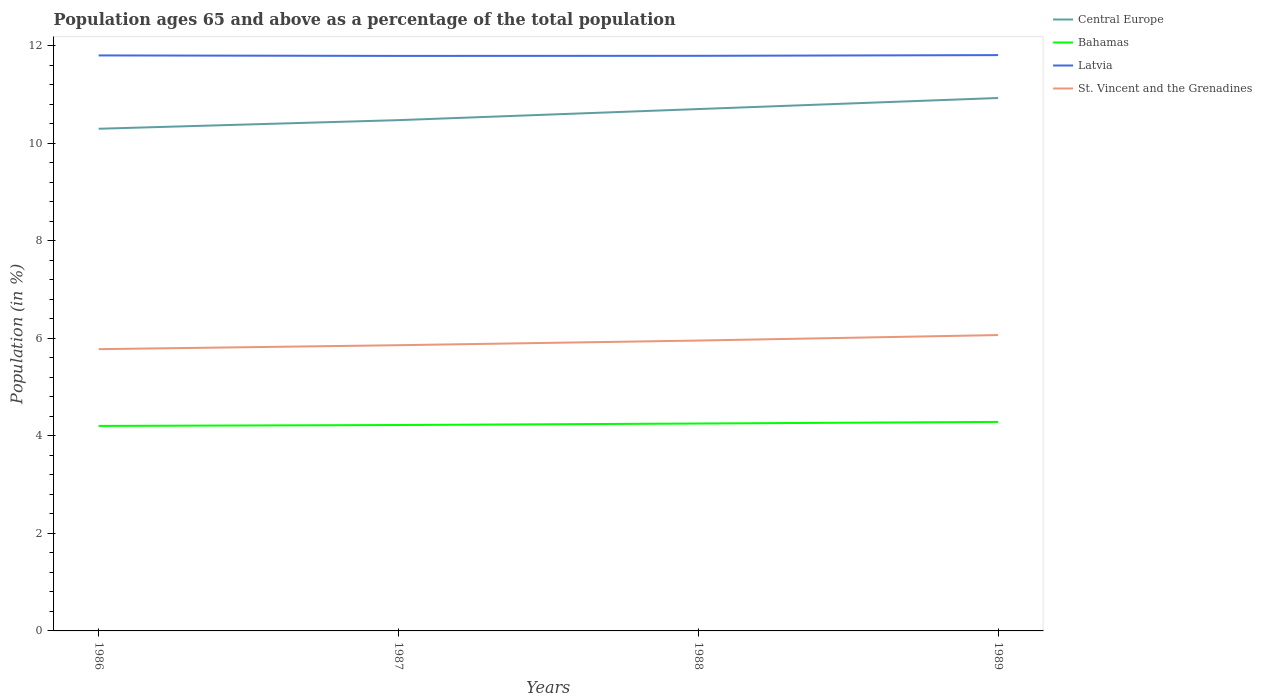Does the line corresponding to Central Europe intersect with the line corresponding to Bahamas?
Make the answer very short. No. Is the number of lines equal to the number of legend labels?
Offer a very short reply. Yes. Across all years, what is the maximum percentage of the population ages 65 and above in St. Vincent and the Grenadines?
Make the answer very short. 5.78. What is the total percentage of the population ages 65 and above in Latvia in the graph?
Your response must be concise. -0.01. What is the difference between the highest and the second highest percentage of the population ages 65 and above in Central Europe?
Offer a very short reply. 0.63. How many lines are there?
Provide a short and direct response. 4. How many years are there in the graph?
Give a very brief answer. 4. What is the difference between two consecutive major ticks on the Y-axis?
Offer a very short reply. 2. Does the graph contain any zero values?
Provide a succinct answer. No. Does the graph contain grids?
Ensure brevity in your answer.  No. How many legend labels are there?
Your response must be concise. 4. How are the legend labels stacked?
Ensure brevity in your answer.  Vertical. What is the title of the graph?
Your answer should be very brief. Population ages 65 and above as a percentage of the total population. What is the label or title of the X-axis?
Keep it short and to the point. Years. What is the Population (in %) of Central Europe in 1986?
Your answer should be compact. 10.29. What is the Population (in %) in Bahamas in 1986?
Offer a very short reply. 4.2. What is the Population (in %) in Latvia in 1986?
Offer a terse response. 11.8. What is the Population (in %) of St. Vincent and the Grenadines in 1986?
Your answer should be very brief. 5.78. What is the Population (in %) in Central Europe in 1987?
Provide a short and direct response. 10.47. What is the Population (in %) of Bahamas in 1987?
Provide a short and direct response. 4.22. What is the Population (in %) of Latvia in 1987?
Keep it short and to the point. 11.79. What is the Population (in %) in St. Vincent and the Grenadines in 1987?
Make the answer very short. 5.86. What is the Population (in %) in Central Europe in 1988?
Offer a terse response. 10.7. What is the Population (in %) in Bahamas in 1988?
Offer a very short reply. 4.25. What is the Population (in %) of Latvia in 1988?
Your answer should be very brief. 11.79. What is the Population (in %) in St. Vincent and the Grenadines in 1988?
Keep it short and to the point. 5.95. What is the Population (in %) in Central Europe in 1989?
Give a very brief answer. 10.92. What is the Population (in %) of Bahamas in 1989?
Offer a terse response. 4.28. What is the Population (in %) of Latvia in 1989?
Provide a succinct answer. 11.8. What is the Population (in %) of St. Vincent and the Grenadines in 1989?
Provide a succinct answer. 6.06. Across all years, what is the maximum Population (in %) of Central Europe?
Provide a succinct answer. 10.92. Across all years, what is the maximum Population (in %) in Bahamas?
Keep it short and to the point. 4.28. Across all years, what is the maximum Population (in %) of Latvia?
Your answer should be compact. 11.8. Across all years, what is the maximum Population (in %) of St. Vincent and the Grenadines?
Offer a very short reply. 6.06. Across all years, what is the minimum Population (in %) of Central Europe?
Provide a succinct answer. 10.29. Across all years, what is the minimum Population (in %) in Bahamas?
Offer a very short reply. 4.2. Across all years, what is the minimum Population (in %) in Latvia?
Offer a very short reply. 11.79. Across all years, what is the minimum Population (in %) in St. Vincent and the Grenadines?
Provide a succinct answer. 5.78. What is the total Population (in %) of Central Europe in the graph?
Your response must be concise. 42.39. What is the total Population (in %) of Bahamas in the graph?
Give a very brief answer. 16.96. What is the total Population (in %) of Latvia in the graph?
Provide a short and direct response. 47.18. What is the total Population (in %) in St. Vincent and the Grenadines in the graph?
Your answer should be compact. 23.65. What is the difference between the Population (in %) in Central Europe in 1986 and that in 1987?
Ensure brevity in your answer.  -0.18. What is the difference between the Population (in %) in Bahamas in 1986 and that in 1987?
Ensure brevity in your answer.  -0.02. What is the difference between the Population (in %) in Latvia in 1986 and that in 1987?
Your answer should be compact. 0.01. What is the difference between the Population (in %) in St. Vincent and the Grenadines in 1986 and that in 1987?
Offer a terse response. -0.08. What is the difference between the Population (in %) in Central Europe in 1986 and that in 1988?
Your response must be concise. -0.4. What is the difference between the Population (in %) of Bahamas in 1986 and that in 1988?
Offer a very short reply. -0.05. What is the difference between the Population (in %) of Latvia in 1986 and that in 1988?
Your answer should be very brief. 0.01. What is the difference between the Population (in %) in St. Vincent and the Grenadines in 1986 and that in 1988?
Give a very brief answer. -0.18. What is the difference between the Population (in %) of Central Europe in 1986 and that in 1989?
Provide a succinct answer. -0.63. What is the difference between the Population (in %) in Bahamas in 1986 and that in 1989?
Offer a terse response. -0.08. What is the difference between the Population (in %) of Latvia in 1986 and that in 1989?
Make the answer very short. -0.01. What is the difference between the Population (in %) in St. Vincent and the Grenadines in 1986 and that in 1989?
Provide a short and direct response. -0.29. What is the difference between the Population (in %) of Central Europe in 1987 and that in 1988?
Offer a terse response. -0.23. What is the difference between the Population (in %) in Bahamas in 1987 and that in 1988?
Offer a terse response. -0.03. What is the difference between the Population (in %) of Latvia in 1987 and that in 1988?
Keep it short and to the point. -0. What is the difference between the Population (in %) of St. Vincent and the Grenadines in 1987 and that in 1988?
Offer a very short reply. -0.1. What is the difference between the Population (in %) of Central Europe in 1987 and that in 1989?
Ensure brevity in your answer.  -0.45. What is the difference between the Population (in %) in Bahamas in 1987 and that in 1989?
Offer a terse response. -0.06. What is the difference between the Population (in %) of Latvia in 1987 and that in 1989?
Provide a short and direct response. -0.02. What is the difference between the Population (in %) in St. Vincent and the Grenadines in 1987 and that in 1989?
Ensure brevity in your answer.  -0.21. What is the difference between the Population (in %) of Central Europe in 1988 and that in 1989?
Your response must be concise. -0.23. What is the difference between the Population (in %) in Bahamas in 1988 and that in 1989?
Provide a short and direct response. -0.03. What is the difference between the Population (in %) in Latvia in 1988 and that in 1989?
Ensure brevity in your answer.  -0.01. What is the difference between the Population (in %) in St. Vincent and the Grenadines in 1988 and that in 1989?
Your answer should be very brief. -0.11. What is the difference between the Population (in %) of Central Europe in 1986 and the Population (in %) of Bahamas in 1987?
Offer a very short reply. 6.07. What is the difference between the Population (in %) of Central Europe in 1986 and the Population (in %) of Latvia in 1987?
Offer a terse response. -1.49. What is the difference between the Population (in %) of Central Europe in 1986 and the Population (in %) of St. Vincent and the Grenadines in 1987?
Provide a short and direct response. 4.44. What is the difference between the Population (in %) of Bahamas in 1986 and the Population (in %) of Latvia in 1987?
Your answer should be compact. -7.58. What is the difference between the Population (in %) of Bahamas in 1986 and the Population (in %) of St. Vincent and the Grenadines in 1987?
Your response must be concise. -1.65. What is the difference between the Population (in %) of Latvia in 1986 and the Population (in %) of St. Vincent and the Grenadines in 1987?
Your response must be concise. 5.94. What is the difference between the Population (in %) in Central Europe in 1986 and the Population (in %) in Bahamas in 1988?
Provide a short and direct response. 6.04. What is the difference between the Population (in %) in Central Europe in 1986 and the Population (in %) in Latvia in 1988?
Your response must be concise. -1.5. What is the difference between the Population (in %) of Central Europe in 1986 and the Population (in %) of St. Vincent and the Grenadines in 1988?
Provide a short and direct response. 4.34. What is the difference between the Population (in %) of Bahamas in 1986 and the Population (in %) of Latvia in 1988?
Offer a terse response. -7.59. What is the difference between the Population (in %) of Bahamas in 1986 and the Population (in %) of St. Vincent and the Grenadines in 1988?
Keep it short and to the point. -1.75. What is the difference between the Population (in %) of Latvia in 1986 and the Population (in %) of St. Vincent and the Grenadines in 1988?
Make the answer very short. 5.84. What is the difference between the Population (in %) in Central Europe in 1986 and the Population (in %) in Bahamas in 1989?
Offer a very short reply. 6.01. What is the difference between the Population (in %) in Central Europe in 1986 and the Population (in %) in Latvia in 1989?
Make the answer very short. -1.51. What is the difference between the Population (in %) in Central Europe in 1986 and the Population (in %) in St. Vincent and the Grenadines in 1989?
Ensure brevity in your answer.  4.23. What is the difference between the Population (in %) in Bahamas in 1986 and the Population (in %) in Latvia in 1989?
Your answer should be very brief. -7.6. What is the difference between the Population (in %) in Bahamas in 1986 and the Population (in %) in St. Vincent and the Grenadines in 1989?
Give a very brief answer. -1.86. What is the difference between the Population (in %) in Latvia in 1986 and the Population (in %) in St. Vincent and the Grenadines in 1989?
Your answer should be compact. 5.73. What is the difference between the Population (in %) of Central Europe in 1987 and the Population (in %) of Bahamas in 1988?
Give a very brief answer. 6.22. What is the difference between the Population (in %) of Central Europe in 1987 and the Population (in %) of Latvia in 1988?
Make the answer very short. -1.32. What is the difference between the Population (in %) in Central Europe in 1987 and the Population (in %) in St. Vincent and the Grenadines in 1988?
Your response must be concise. 4.52. What is the difference between the Population (in %) in Bahamas in 1987 and the Population (in %) in Latvia in 1988?
Provide a succinct answer. -7.57. What is the difference between the Population (in %) of Bahamas in 1987 and the Population (in %) of St. Vincent and the Grenadines in 1988?
Your answer should be very brief. -1.73. What is the difference between the Population (in %) of Latvia in 1987 and the Population (in %) of St. Vincent and the Grenadines in 1988?
Keep it short and to the point. 5.83. What is the difference between the Population (in %) in Central Europe in 1987 and the Population (in %) in Bahamas in 1989?
Offer a terse response. 6.19. What is the difference between the Population (in %) of Central Europe in 1987 and the Population (in %) of Latvia in 1989?
Give a very brief answer. -1.33. What is the difference between the Population (in %) in Central Europe in 1987 and the Population (in %) in St. Vincent and the Grenadines in 1989?
Your answer should be very brief. 4.41. What is the difference between the Population (in %) in Bahamas in 1987 and the Population (in %) in Latvia in 1989?
Ensure brevity in your answer.  -7.58. What is the difference between the Population (in %) of Bahamas in 1987 and the Population (in %) of St. Vincent and the Grenadines in 1989?
Keep it short and to the point. -1.84. What is the difference between the Population (in %) of Latvia in 1987 and the Population (in %) of St. Vincent and the Grenadines in 1989?
Provide a succinct answer. 5.72. What is the difference between the Population (in %) of Central Europe in 1988 and the Population (in %) of Bahamas in 1989?
Your answer should be very brief. 6.41. What is the difference between the Population (in %) in Central Europe in 1988 and the Population (in %) in Latvia in 1989?
Make the answer very short. -1.11. What is the difference between the Population (in %) in Central Europe in 1988 and the Population (in %) in St. Vincent and the Grenadines in 1989?
Give a very brief answer. 4.63. What is the difference between the Population (in %) of Bahamas in 1988 and the Population (in %) of Latvia in 1989?
Offer a very short reply. -7.55. What is the difference between the Population (in %) in Bahamas in 1988 and the Population (in %) in St. Vincent and the Grenadines in 1989?
Keep it short and to the point. -1.81. What is the difference between the Population (in %) in Latvia in 1988 and the Population (in %) in St. Vincent and the Grenadines in 1989?
Keep it short and to the point. 5.72. What is the average Population (in %) of Central Europe per year?
Your answer should be compact. 10.6. What is the average Population (in %) in Bahamas per year?
Your answer should be very brief. 4.24. What is the average Population (in %) of Latvia per year?
Provide a succinct answer. 11.79. What is the average Population (in %) of St. Vincent and the Grenadines per year?
Offer a very short reply. 5.91. In the year 1986, what is the difference between the Population (in %) in Central Europe and Population (in %) in Bahamas?
Your answer should be very brief. 6.09. In the year 1986, what is the difference between the Population (in %) of Central Europe and Population (in %) of Latvia?
Make the answer very short. -1.5. In the year 1986, what is the difference between the Population (in %) of Central Europe and Population (in %) of St. Vincent and the Grenadines?
Your answer should be very brief. 4.52. In the year 1986, what is the difference between the Population (in %) in Bahamas and Population (in %) in Latvia?
Ensure brevity in your answer.  -7.59. In the year 1986, what is the difference between the Population (in %) of Bahamas and Population (in %) of St. Vincent and the Grenadines?
Make the answer very short. -1.57. In the year 1986, what is the difference between the Population (in %) of Latvia and Population (in %) of St. Vincent and the Grenadines?
Your response must be concise. 6.02. In the year 1987, what is the difference between the Population (in %) of Central Europe and Population (in %) of Bahamas?
Your response must be concise. 6.25. In the year 1987, what is the difference between the Population (in %) of Central Europe and Population (in %) of Latvia?
Your response must be concise. -1.32. In the year 1987, what is the difference between the Population (in %) of Central Europe and Population (in %) of St. Vincent and the Grenadines?
Give a very brief answer. 4.61. In the year 1987, what is the difference between the Population (in %) in Bahamas and Population (in %) in Latvia?
Offer a terse response. -7.57. In the year 1987, what is the difference between the Population (in %) of Bahamas and Population (in %) of St. Vincent and the Grenadines?
Provide a short and direct response. -1.64. In the year 1987, what is the difference between the Population (in %) in Latvia and Population (in %) in St. Vincent and the Grenadines?
Your response must be concise. 5.93. In the year 1988, what is the difference between the Population (in %) in Central Europe and Population (in %) in Bahamas?
Ensure brevity in your answer.  6.45. In the year 1988, what is the difference between the Population (in %) of Central Europe and Population (in %) of Latvia?
Offer a very short reply. -1.09. In the year 1988, what is the difference between the Population (in %) in Central Europe and Population (in %) in St. Vincent and the Grenadines?
Give a very brief answer. 4.75. In the year 1988, what is the difference between the Population (in %) in Bahamas and Population (in %) in Latvia?
Your response must be concise. -7.54. In the year 1988, what is the difference between the Population (in %) in Bahamas and Population (in %) in St. Vincent and the Grenadines?
Your answer should be compact. -1.7. In the year 1988, what is the difference between the Population (in %) in Latvia and Population (in %) in St. Vincent and the Grenadines?
Give a very brief answer. 5.84. In the year 1989, what is the difference between the Population (in %) in Central Europe and Population (in %) in Bahamas?
Give a very brief answer. 6.64. In the year 1989, what is the difference between the Population (in %) in Central Europe and Population (in %) in Latvia?
Your answer should be very brief. -0.88. In the year 1989, what is the difference between the Population (in %) in Central Europe and Population (in %) in St. Vincent and the Grenadines?
Offer a terse response. 4.86. In the year 1989, what is the difference between the Population (in %) of Bahamas and Population (in %) of Latvia?
Keep it short and to the point. -7.52. In the year 1989, what is the difference between the Population (in %) of Bahamas and Population (in %) of St. Vincent and the Grenadines?
Keep it short and to the point. -1.78. In the year 1989, what is the difference between the Population (in %) in Latvia and Population (in %) in St. Vincent and the Grenadines?
Your answer should be very brief. 5.74. What is the ratio of the Population (in %) in Central Europe in 1986 to that in 1987?
Your answer should be compact. 0.98. What is the ratio of the Population (in %) in Latvia in 1986 to that in 1987?
Provide a short and direct response. 1. What is the ratio of the Population (in %) of St. Vincent and the Grenadines in 1986 to that in 1987?
Provide a short and direct response. 0.99. What is the ratio of the Population (in %) of Central Europe in 1986 to that in 1988?
Offer a very short reply. 0.96. What is the ratio of the Population (in %) of Bahamas in 1986 to that in 1988?
Your answer should be compact. 0.99. What is the ratio of the Population (in %) of Latvia in 1986 to that in 1988?
Offer a terse response. 1. What is the ratio of the Population (in %) of St. Vincent and the Grenadines in 1986 to that in 1988?
Provide a succinct answer. 0.97. What is the ratio of the Population (in %) of Central Europe in 1986 to that in 1989?
Provide a short and direct response. 0.94. What is the ratio of the Population (in %) in Bahamas in 1986 to that in 1989?
Your answer should be very brief. 0.98. What is the ratio of the Population (in %) of St. Vincent and the Grenadines in 1986 to that in 1989?
Give a very brief answer. 0.95. What is the ratio of the Population (in %) of Central Europe in 1987 to that in 1988?
Your response must be concise. 0.98. What is the ratio of the Population (in %) of Bahamas in 1987 to that in 1988?
Your response must be concise. 0.99. What is the ratio of the Population (in %) of Central Europe in 1987 to that in 1989?
Ensure brevity in your answer.  0.96. What is the ratio of the Population (in %) in Bahamas in 1987 to that in 1989?
Keep it short and to the point. 0.99. What is the ratio of the Population (in %) of St. Vincent and the Grenadines in 1987 to that in 1989?
Your answer should be very brief. 0.97. What is the ratio of the Population (in %) in Central Europe in 1988 to that in 1989?
Offer a very short reply. 0.98. What is the ratio of the Population (in %) of Latvia in 1988 to that in 1989?
Provide a succinct answer. 1. What is the ratio of the Population (in %) in St. Vincent and the Grenadines in 1988 to that in 1989?
Provide a succinct answer. 0.98. What is the difference between the highest and the second highest Population (in %) of Central Europe?
Give a very brief answer. 0.23. What is the difference between the highest and the second highest Population (in %) of Bahamas?
Ensure brevity in your answer.  0.03. What is the difference between the highest and the second highest Population (in %) in Latvia?
Offer a very short reply. 0.01. What is the difference between the highest and the second highest Population (in %) of St. Vincent and the Grenadines?
Provide a succinct answer. 0.11. What is the difference between the highest and the lowest Population (in %) of Central Europe?
Provide a short and direct response. 0.63. What is the difference between the highest and the lowest Population (in %) in Bahamas?
Your answer should be very brief. 0.08. What is the difference between the highest and the lowest Population (in %) in Latvia?
Your answer should be compact. 0.02. What is the difference between the highest and the lowest Population (in %) in St. Vincent and the Grenadines?
Your answer should be compact. 0.29. 